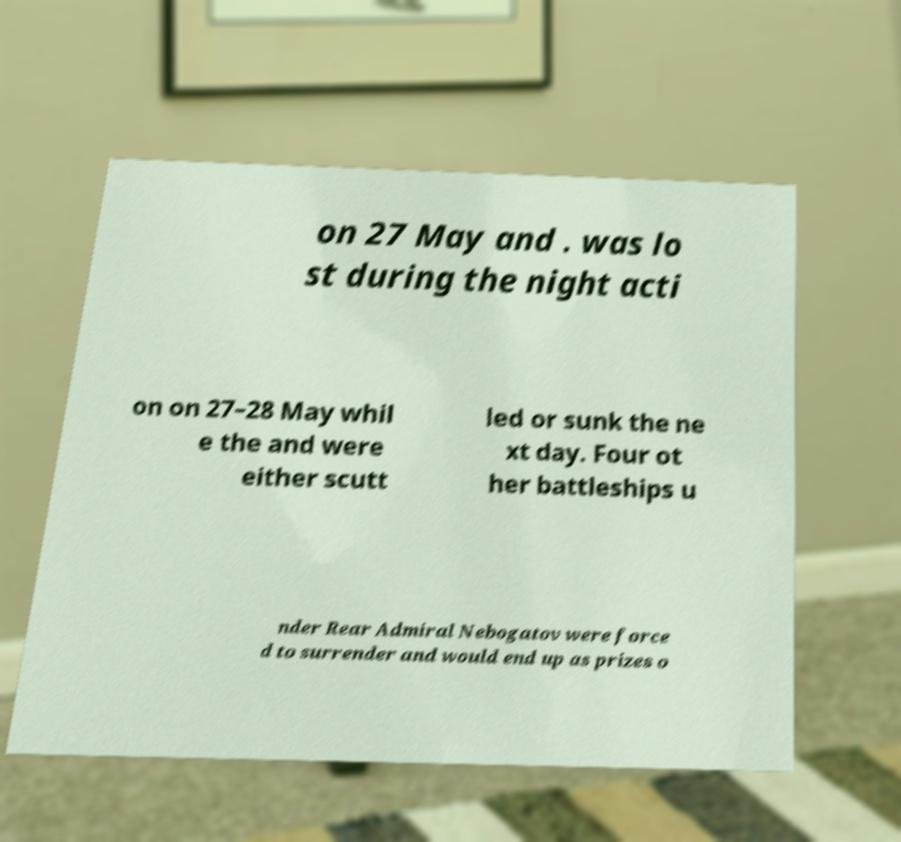Can you read and provide the text displayed in the image?This photo seems to have some interesting text. Can you extract and type it out for me? on 27 May and . was lo st during the night acti on on 27–28 May whil e the and were either scutt led or sunk the ne xt day. Four ot her battleships u nder Rear Admiral Nebogatov were force d to surrender and would end up as prizes o 